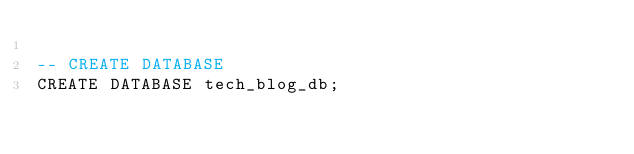<code> <loc_0><loc_0><loc_500><loc_500><_SQL_>
-- CREATE DATABASE
CREATE DATABASE tech_blog_db;

</code> 